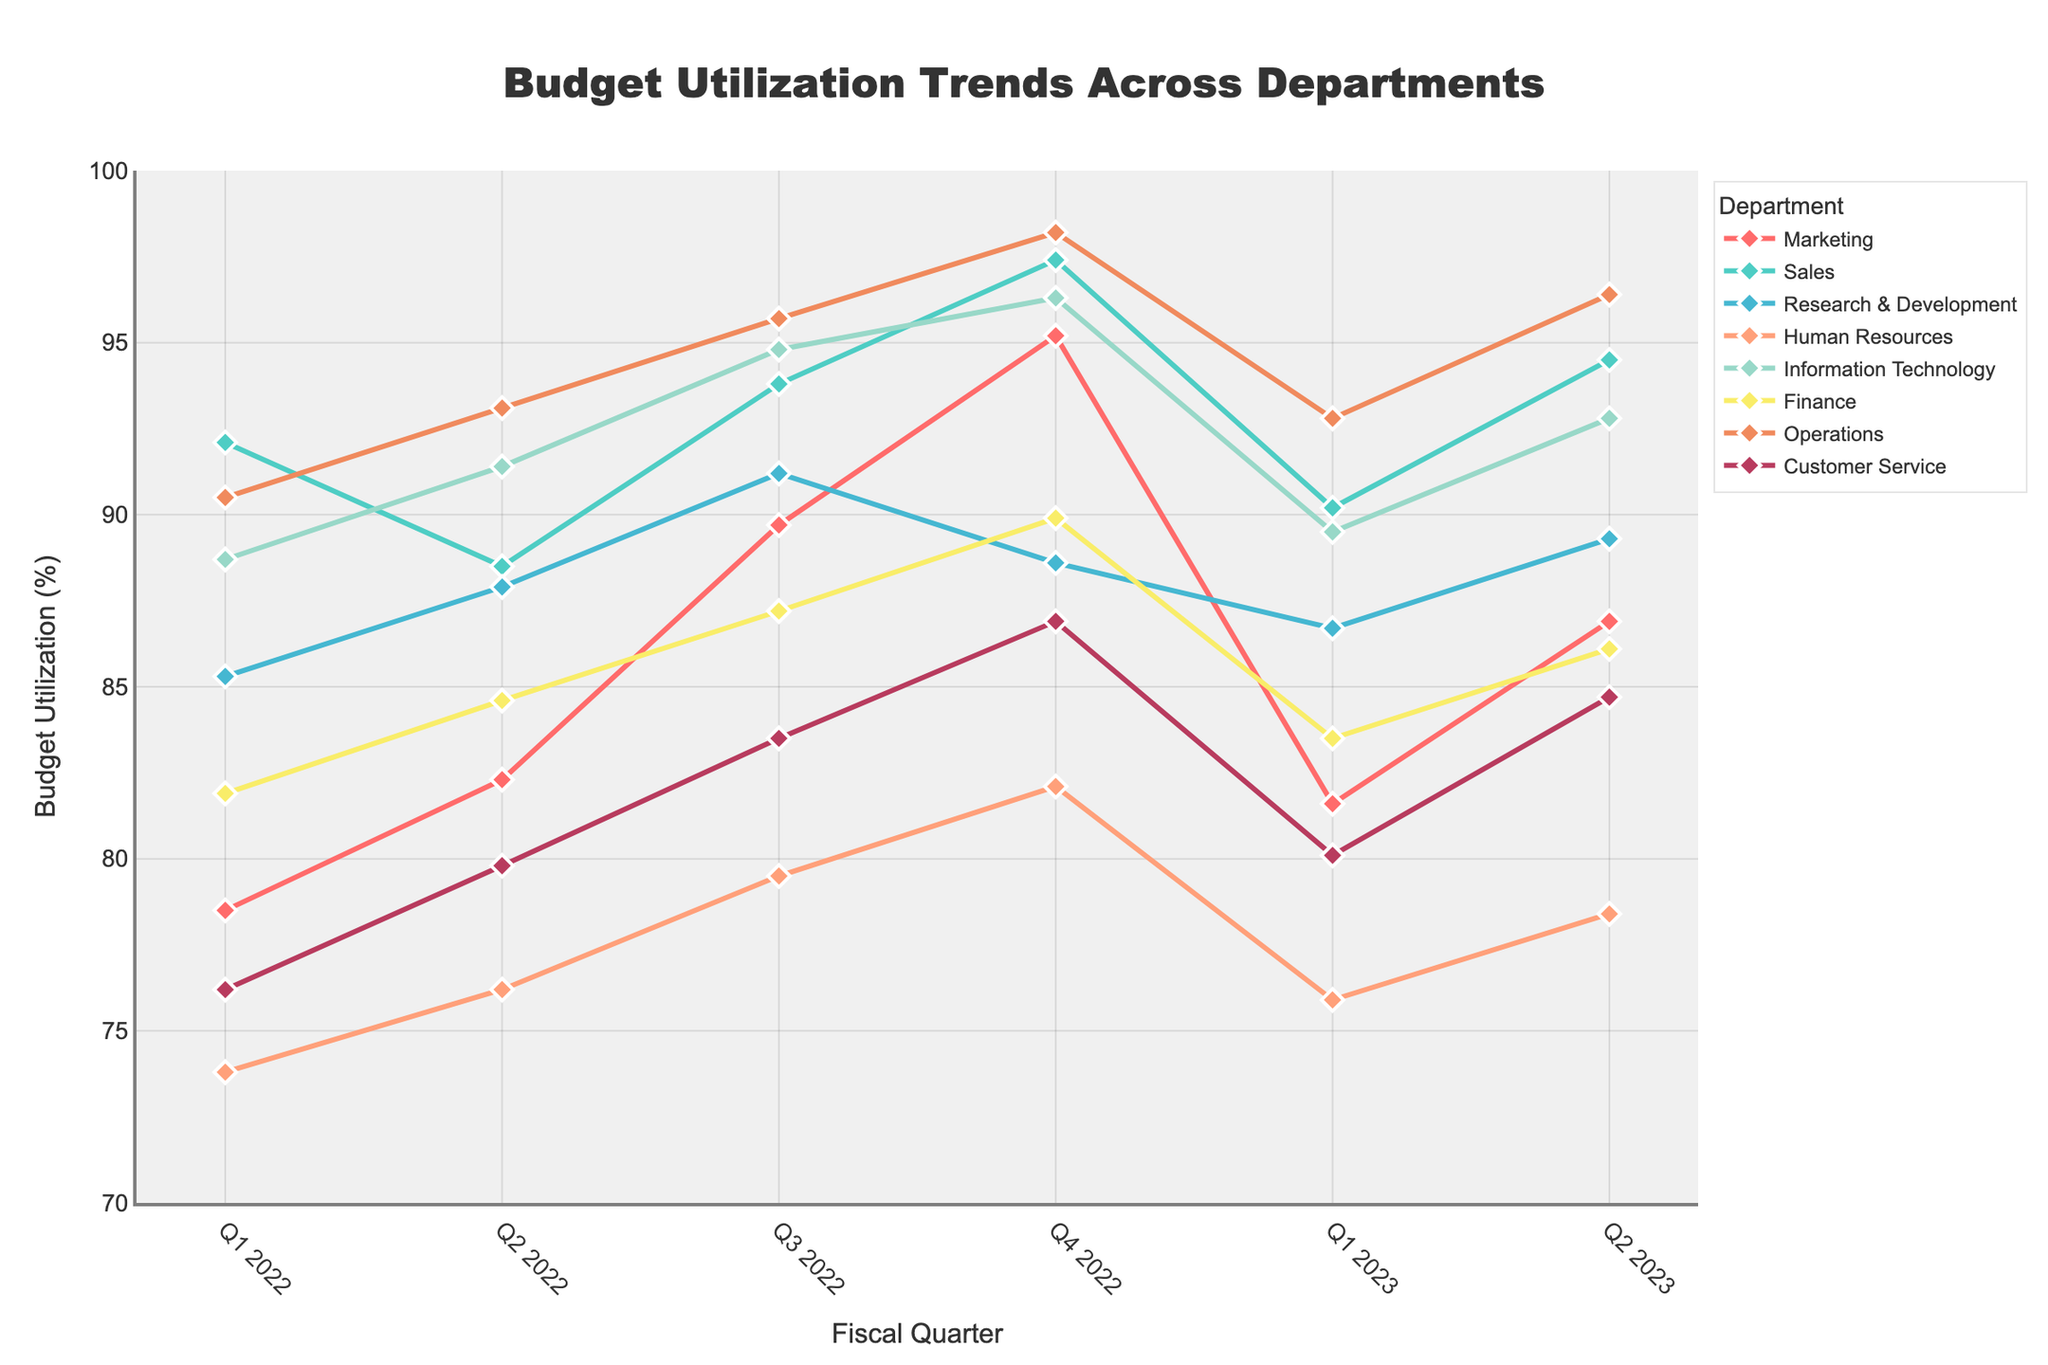What's the trend for the Marketing department from Q1 2022 to Q2 2023? To determine the trend for the Marketing department, observe the line representing the Marketing department from Q1 2022 to Q2 2023. Notice the overall direction. The Budget Utilization starts at 78.5 in Q1 2022, increases to 95.2 in Q4 2022, then dips in Q1 2023 to 81.6, and rises to 86.9 in Q2 2023.
Answer: Increases, then decreases, and increases again Which department had the highest budget utilization in Q4 2022? To find this, look at the budget utilization values for each department in Q4 2022. The highest value is 98.2, which belongs to the Operations department.
Answer: Operations Between Sales and Finance, which department showed a greater increase from Q4 2022 to Q1 2023? Calculate the difference for Sales and Finance from Q4 2022 to Q1 2023. Sales: 97.4 - 90.2 = -7.2, Finance: 89.9 - 83.5 = -6.4. Both departments show a decrease, but Sales had a greater decrease.
Answer: Finance Which department has the least variability in budget utilization across all quarters? To assess variability, observe how much the values fluctuate for each department across quarters. The Research & Development department shows less variation compared to others, ranging from 85.3 to 91.2.
Answer: Research & Development What is the average budget utilization for the Information Technology department in the second half of 2022? Calculate the average for Q3 2022 and Q4 2022 for the Information Technology department. (94.8 + 96.3) / 2 = 95.55
Answer: 95.55 Compare the budget utilization trends between Operations and Customer Service. Which one shows a more consistent increase over the quarters? Plot and compare the trends visually. Operations show a smoother and more consistent increase across the quarters, while Customer Service shows some fluctuations.
Answer: Operations What is the largest drop in budget utilization for any department between two consecutive quarters? Identify the largest decrease by calculating the budget utilization difference for all departments between every pair of consecutive quarters. The largest drop is for Sales from Q4 2022 (97.4) to Q1 2023 (90.2), with a decrease of 7.2.
Answer: 7.2 In Q2 2023, which department had its budget utilization closest to the overall average budget utilization of all departments? Calculate the overall average for Q2 2023 and compare the values. Average = (86.9 + 94.5 + 89.3 + 78.4 + 92.8 + 86.1 + 96.4 + 84.7) / 8 = 88.89. Finance's value (86.1) is closest to this average.
Answer: Finance 